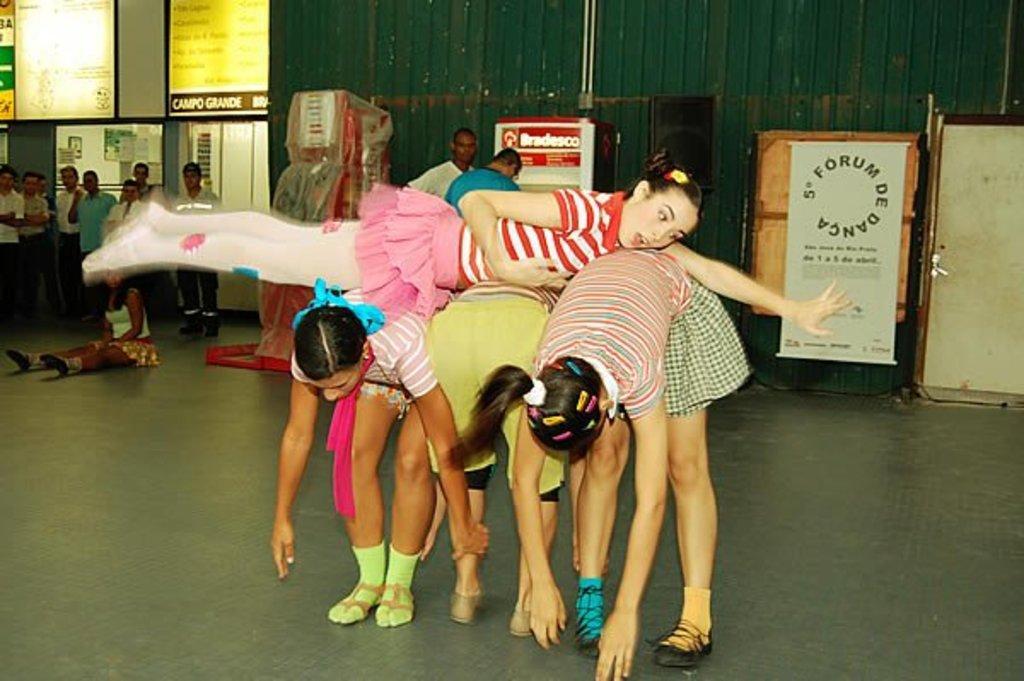Could you give a brief overview of what you see in this image? In this picture we can see four persons in the front, there are some people standing and a girl is sitting on the left side, in the background there are words, we can see some text on these boards, on the right side there is a chart. 